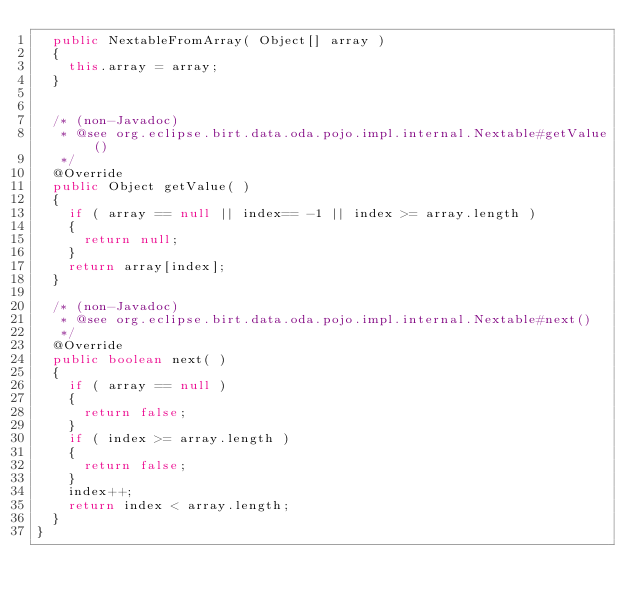Convert code to text. <code><loc_0><loc_0><loc_500><loc_500><_Java_>	public NextableFromArray( Object[] array )
	{
		this.array = array;
	}
	

	/* (non-Javadoc)
	 * @see org.eclipse.birt.data.oda.pojo.impl.internal.Nextable#getValue()
	 */
	@Override
	public Object getValue( )
	{
		if ( array == null || index== -1 || index >= array.length )
		{
			return null;
		}
		return array[index];
	}

	/* (non-Javadoc)
	 * @see org.eclipse.birt.data.oda.pojo.impl.internal.Nextable#next()
	 */
	@Override
	public boolean next( ) 
	{
		if ( array == null )
		{
			return false;
		}
		if ( index >= array.length )
		{
			return false;
		}
		index++;
		return index < array.length;
	}
}
</code> 